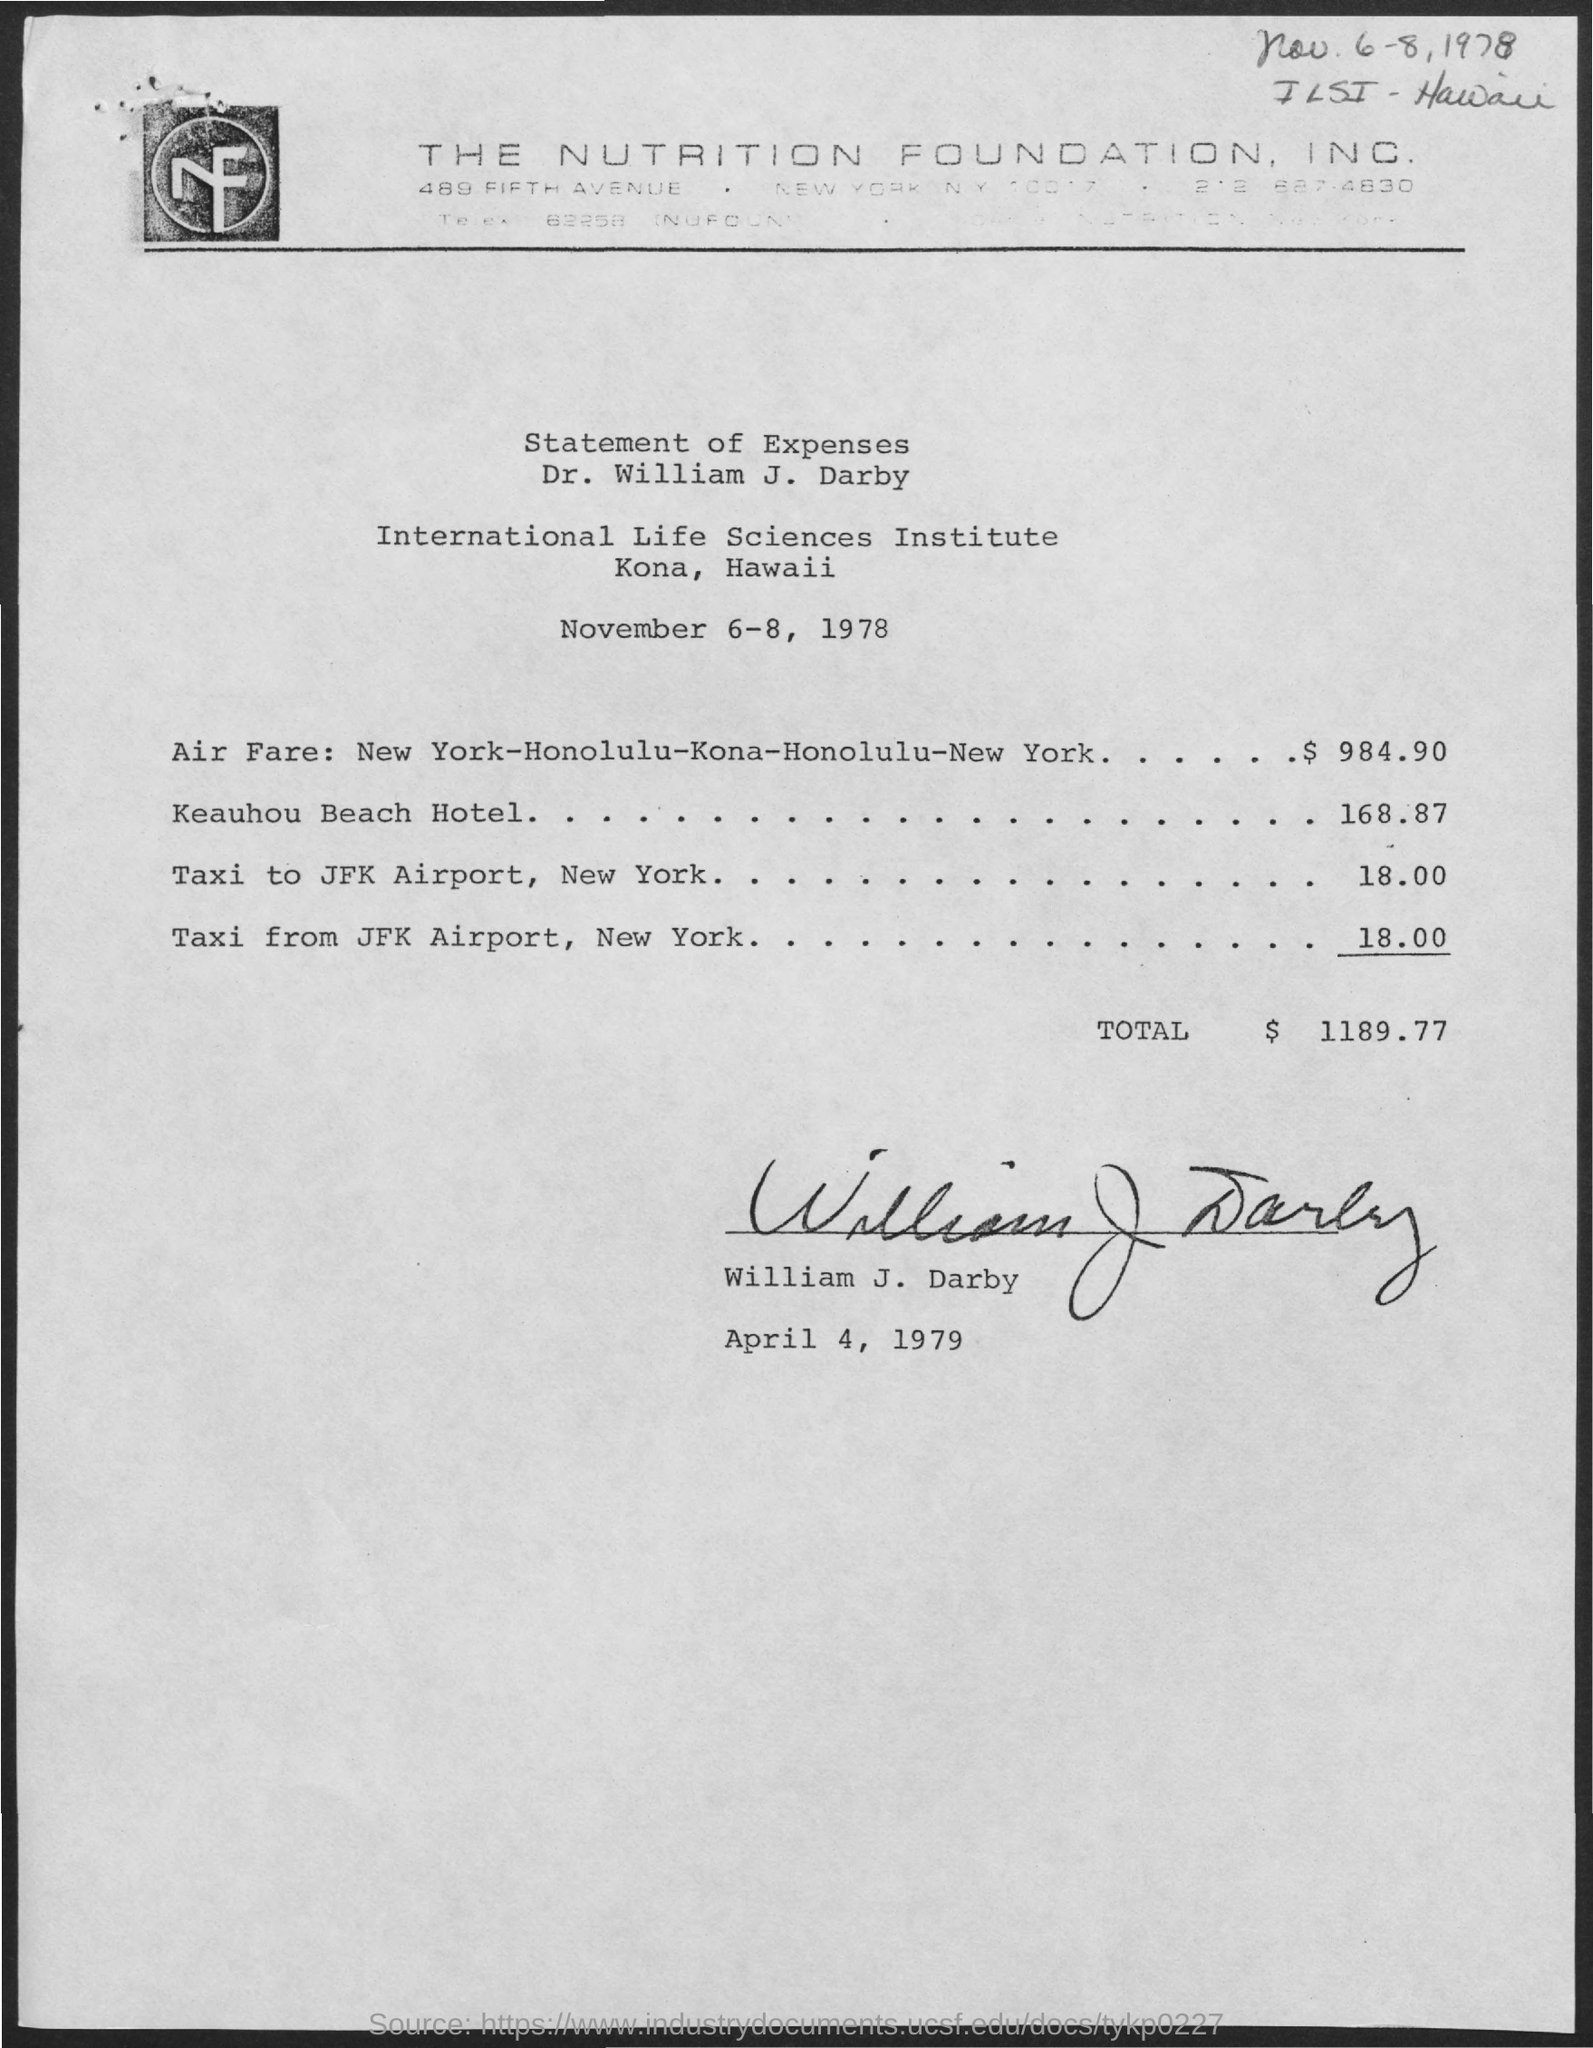Mention a couple of crucial points in this snapshot. The expenses for the Keauhou Beach Hotel, including the cost of 168.87, will be considered. The expenses for a taxi from John F. Kennedy International Airport in New York are approximately $18.00. The International Life Sciences Institute is the name of the institute mentioned in the given page. The cost of airfare for traveling from New York to Honolulu, then to Kona, and back to New York is $984.90. The total expenses mentioned in the given page are $1189.77. 